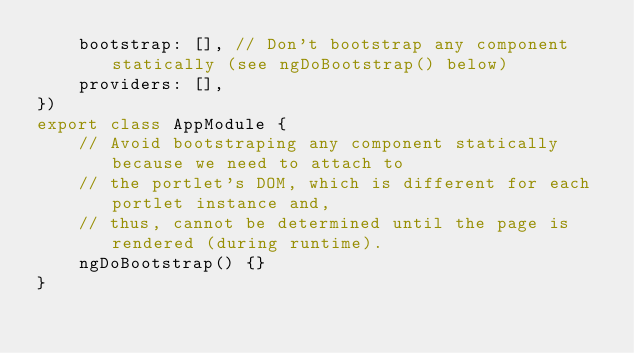<code> <loc_0><loc_0><loc_500><loc_500><_TypeScript_>	bootstrap: [], // Don't bootstrap any component statically (see ngDoBootstrap() below)
	providers: [],
})
export class AppModule {
	// Avoid bootstraping any component statically because we need to attach to
	// the portlet's DOM, which is different for each portlet instance and,
	// thus, cannot be determined until the page is rendered (during runtime).
	ngDoBootstrap() {}
}
</code> 